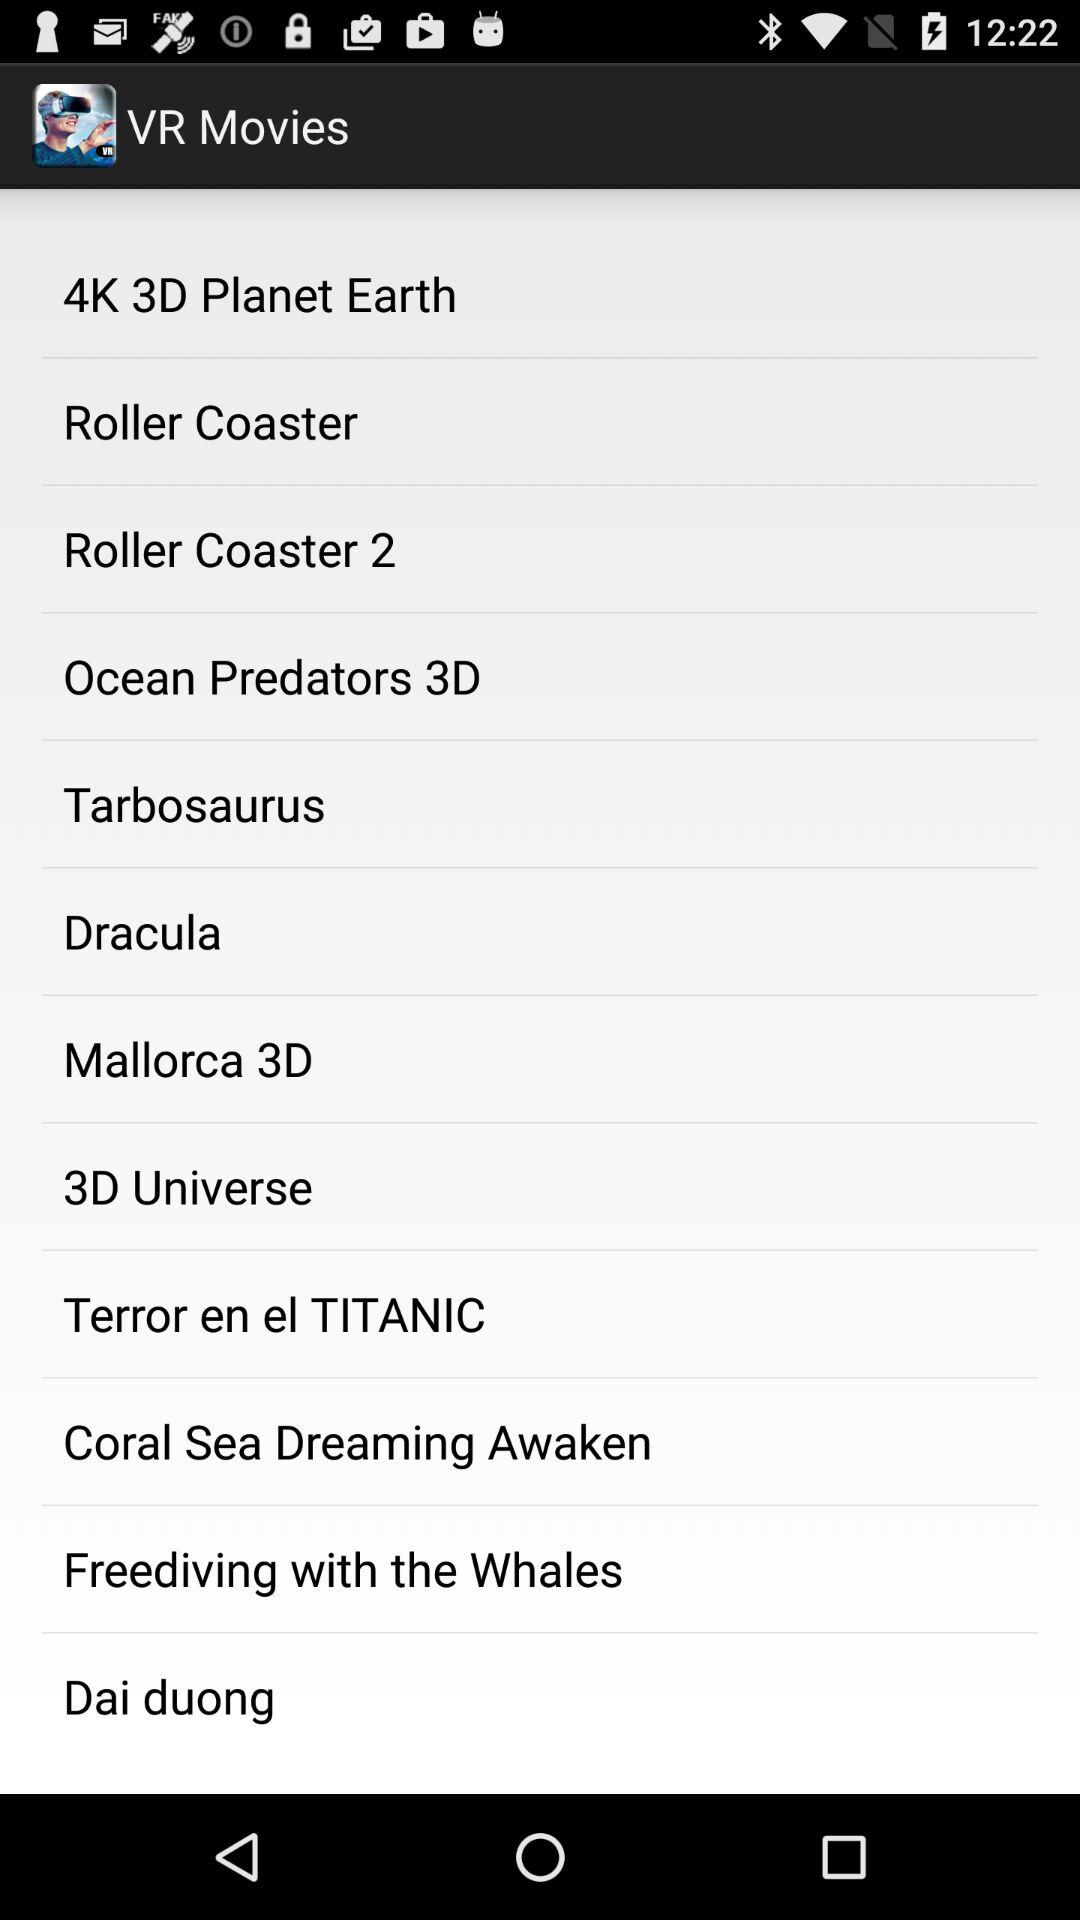What is the app name? The app name is "VR Movies". 